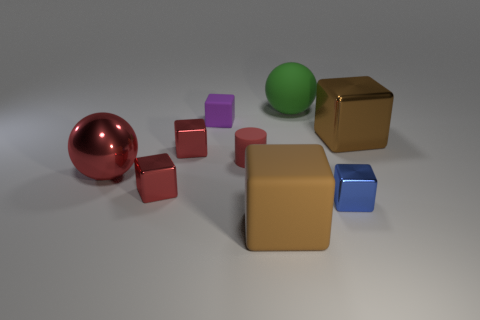Is there another large cube of the same color as the large shiny cube?
Make the answer very short. Yes. Is the material of the red ball the same as the blue cube?
Your answer should be compact. Yes. What number of big green rubber things have the same shape as the brown metallic object?
Your response must be concise. 0. There is a big brown thing that is the same material as the red sphere; what shape is it?
Offer a very short reply. Cube. What is the color of the large thing that is on the left side of the rubber thing in front of the blue cube?
Your answer should be compact. Red. Does the small cylinder have the same color as the shiny sphere?
Give a very brief answer. Yes. There is a brown cube that is behind the red metal block that is in front of the red rubber cylinder; what is it made of?
Your response must be concise. Metal. There is a small blue thing that is the same shape as the purple thing; what is it made of?
Your response must be concise. Metal. There is a rubber object in front of the ball in front of the tiny purple rubber thing; is there a matte object behind it?
Offer a terse response. Yes. What number of other things are there of the same color as the rubber sphere?
Provide a short and direct response. 0. 